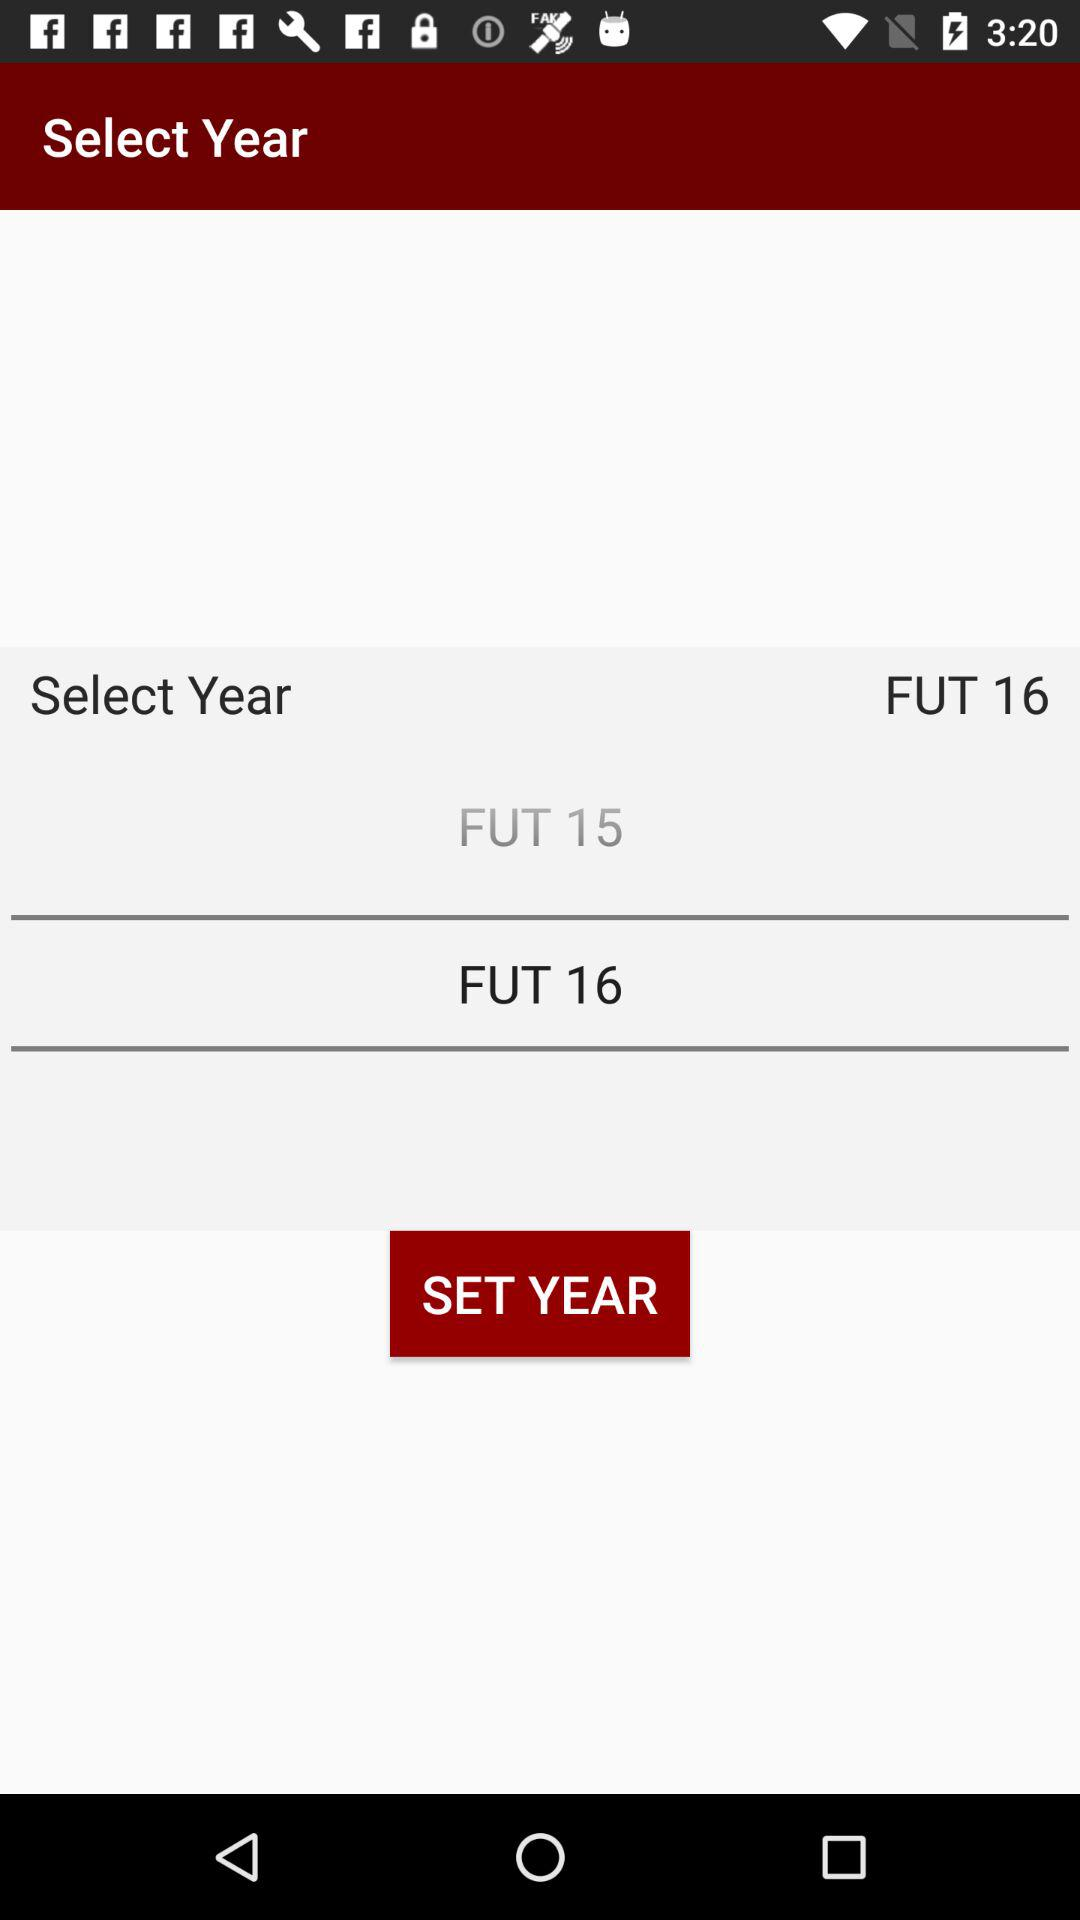Which year is selected? The selected year is "FUT 16". 